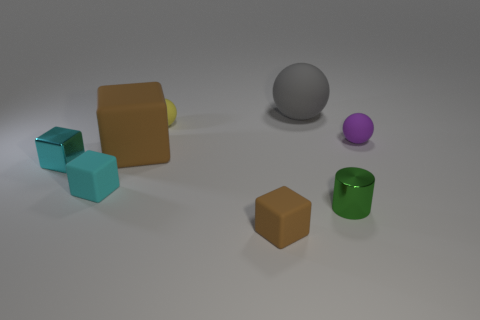Are the big brown thing and the tiny sphere on the left side of the large ball made of the same material?
Offer a terse response. Yes. There is a small matte object that is to the right of the gray object; is its color the same as the big rubber sphere?
Offer a terse response. No. The tiny thing that is both behind the large matte cube and to the left of the small cylinder is made of what material?
Your answer should be compact. Rubber. How big is the cyan metal cube?
Make the answer very short. Small. There is a large rubber block; is it the same color as the small rubber thing behind the purple object?
Ensure brevity in your answer.  No. What number of other objects are the same color as the shiny cylinder?
Your response must be concise. 0. Does the matte sphere on the right side of the green shiny cylinder have the same size as the brown object behind the tiny cylinder?
Offer a terse response. No. What color is the big thing that is behind the tiny yellow sphere?
Give a very brief answer. Gray. Is the number of tiny purple things behind the tiny purple rubber thing less than the number of blue metal things?
Provide a succinct answer. No. Does the purple sphere have the same material as the large cube?
Keep it short and to the point. Yes. 